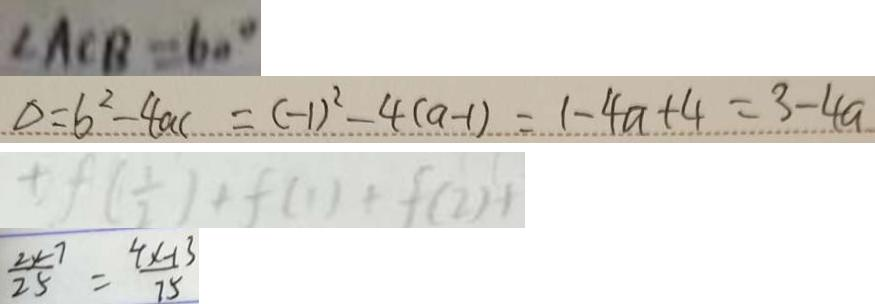Convert formula to latex. <formula><loc_0><loc_0><loc_500><loc_500>\angle A C B = 6 0 ^ { \circ } 
 \Delta = b ^ { 2 } - 4 a c = ( - 1 ) ^ { 2 } - 4 ( a - 1 ) = 1 - 4 a + 4 = 3 - 4 a 
 \pm f ( \frac { 1 } { 2 } ) + f ( 1 ) + f ( 2 ) + 
 \frac { 2 x - 7 } { 2 5 } = \frac { 4 x - 1 3 } { 7 5 }</formula> 